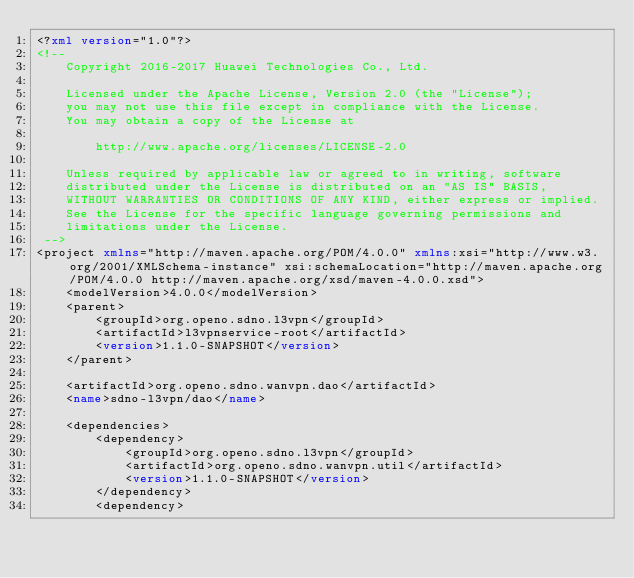<code> <loc_0><loc_0><loc_500><loc_500><_XML_><?xml version="1.0"?>
<!--
    Copyright 2016-2017 Huawei Technologies Co., Ltd.
   
    Licensed under the Apache License, Version 2.0 (the "License");
    you may not use this file except in compliance with the License.
    You may obtain a copy of the License at
   
        http://www.apache.org/licenses/LICENSE-2.0
   
    Unless required by applicable law or agreed to in writing, software
    distributed under the License is distributed on an "AS IS" BASIS,
    WITHOUT WARRANTIES OR CONDITIONS OF ANY KIND, either express or implied.
    See the License for the specific language governing permissions and
    limitations under the License.
 -->
<project xmlns="http://maven.apache.org/POM/4.0.0" xmlns:xsi="http://www.w3.org/2001/XMLSchema-instance" xsi:schemaLocation="http://maven.apache.org/POM/4.0.0 http://maven.apache.org/xsd/maven-4.0.0.xsd">
    <modelVersion>4.0.0</modelVersion>
    <parent>
        <groupId>org.openo.sdno.l3vpn</groupId>
        <artifactId>l3vpnservice-root</artifactId>
        <version>1.1.0-SNAPSHOT</version>
    </parent>

    <artifactId>org.openo.sdno.wanvpn.dao</artifactId>
    <name>sdno-l3vpn/dao</name>

    <dependencies>
        <dependency>
            <groupId>org.openo.sdno.l3vpn</groupId>
            <artifactId>org.openo.sdno.wanvpn.util</artifactId>
            <version>1.1.0-SNAPSHOT</version>
        </dependency>
        <dependency></code> 